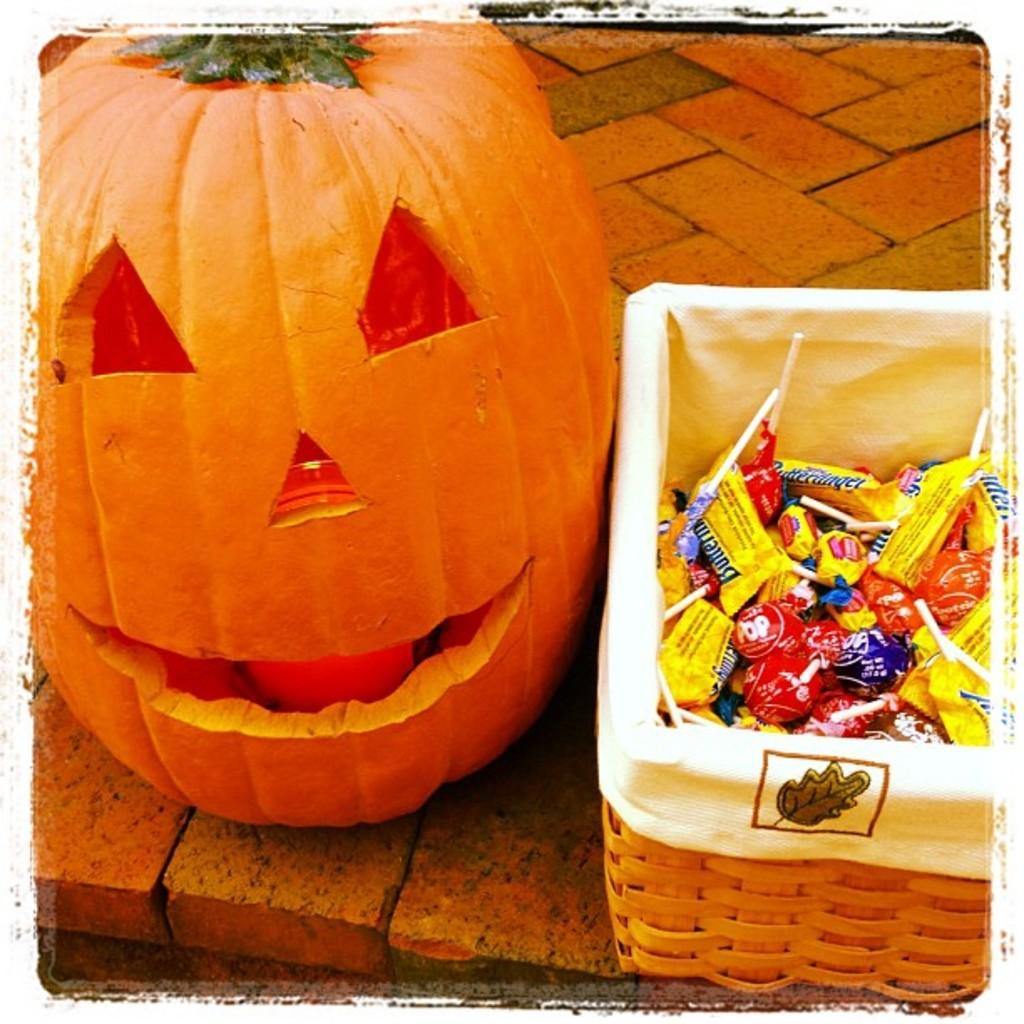What type of vegetable can be seen in the image that is orange in color? There is a vegetable in the image that is orange in color, but the specific type of vegetable is not mentioned in the facts. What type of food is present in the image besides the vegetable? There are chocolates in the image. How are the chocolates arranged in the image? The chocolates are in a basket. What colors can be seen among the chocolates in the image? The chocolates are in multiple colors. What type of road can be seen in the image? There is no road present in the image; it features a vegetable and chocolates. 